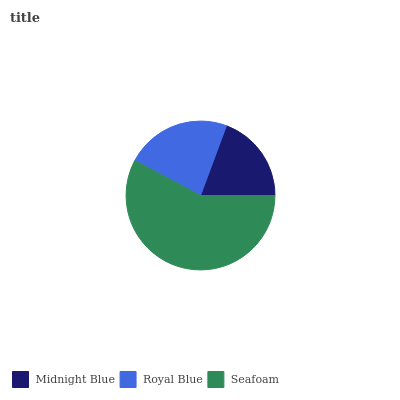Is Midnight Blue the minimum?
Answer yes or no. Yes. Is Seafoam the maximum?
Answer yes or no. Yes. Is Royal Blue the minimum?
Answer yes or no. No. Is Royal Blue the maximum?
Answer yes or no. No. Is Royal Blue greater than Midnight Blue?
Answer yes or no. Yes. Is Midnight Blue less than Royal Blue?
Answer yes or no. Yes. Is Midnight Blue greater than Royal Blue?
Answer yes or no. No. Is Royal Blue less than Midnight Blue?
Answer yes or no. No. Is Royal Blue the high median?
Answer yes or no. Yes. Is Royal Blue the low median?
Answer yes or no. Yes. Is Midnight Blue the high median?
Answer yes or no. No. Is Midnight Blue the low median?
Answer yes or no. No. 